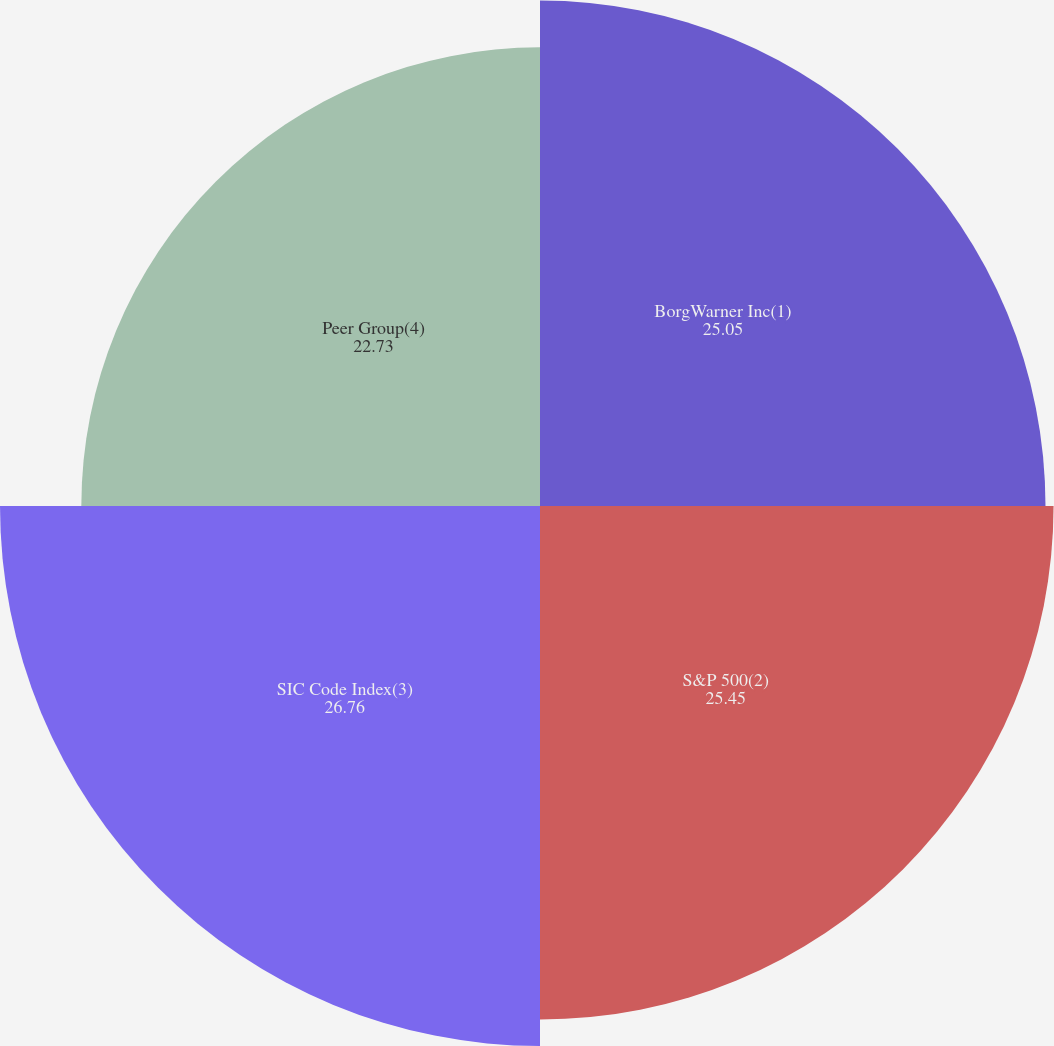<chart> <loc_0><loc_0><loc_500><loc_500><pie_chart><fcel>BorgWarner Inc(1)<fcel>S&P 500(2)<fcel>SIC Code Index(3)<fcel>Peer Group(4)<nl><fcel>25.05%<fcel>25.45%<fcel>26.76%<fcel>22.73%<nl></chart> 